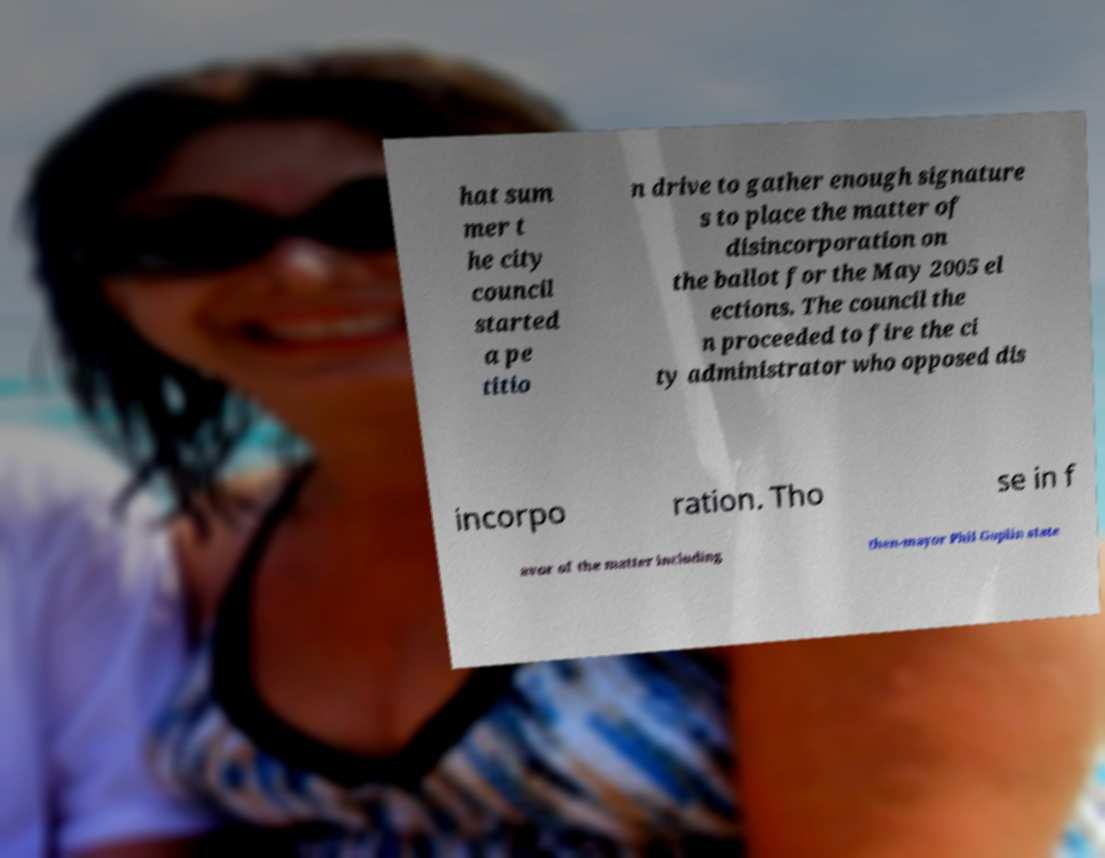Could you extract and type out the text from this image? hat sum mer t he city council started a pe titio n drive to gather enough signature s to place the matter of disincorporation on the ballot for the May 2005 el ections. The council the n proceeded to fire the ci ty administrator who opposed dis incorpo ration. Tho se in f avor of the matter including then-mayor Phil Goplin state 